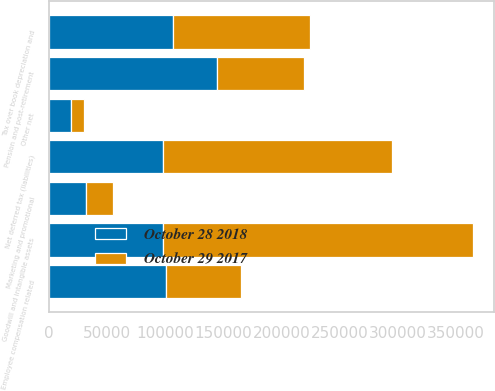Convert chart to OTSL. <chart><loc_0><loc_0><loc_500><loc_500><stacked_bar_chart><ecel><fcel>Goodwill and intangible assets<fcel>Tax over book depreciation and<fcel>Other net<fcel>Pension and post-retirement<fcel>Employee compensation related<fcel>Marketing and promotional<fcel>Net deferred tax (liabilities)<nl><fcel>October 29 2017<fcel>266709<fcel>117861<fcel>11221<fcel>75501<fcel>64852<fcel>22595<fcel>197093<nl><fcel>October 28 2018<fcel>98410<fcel>107076<fcel>18657<fcel>144392<fcel>100311<fcel>32011<fcel>98410<nl></chart> 